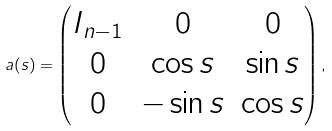Convert formula to latex. <formula><loc_0><loc_0><loc_500><loc_500>a ( s ) = \begin{pmatrix} I _ { n - 1 } & 0 & 0 \\ 0 & \cos s & \sin s \\ 0 & - \sin s & \cos s \end{pmatrix} ,</formula> 